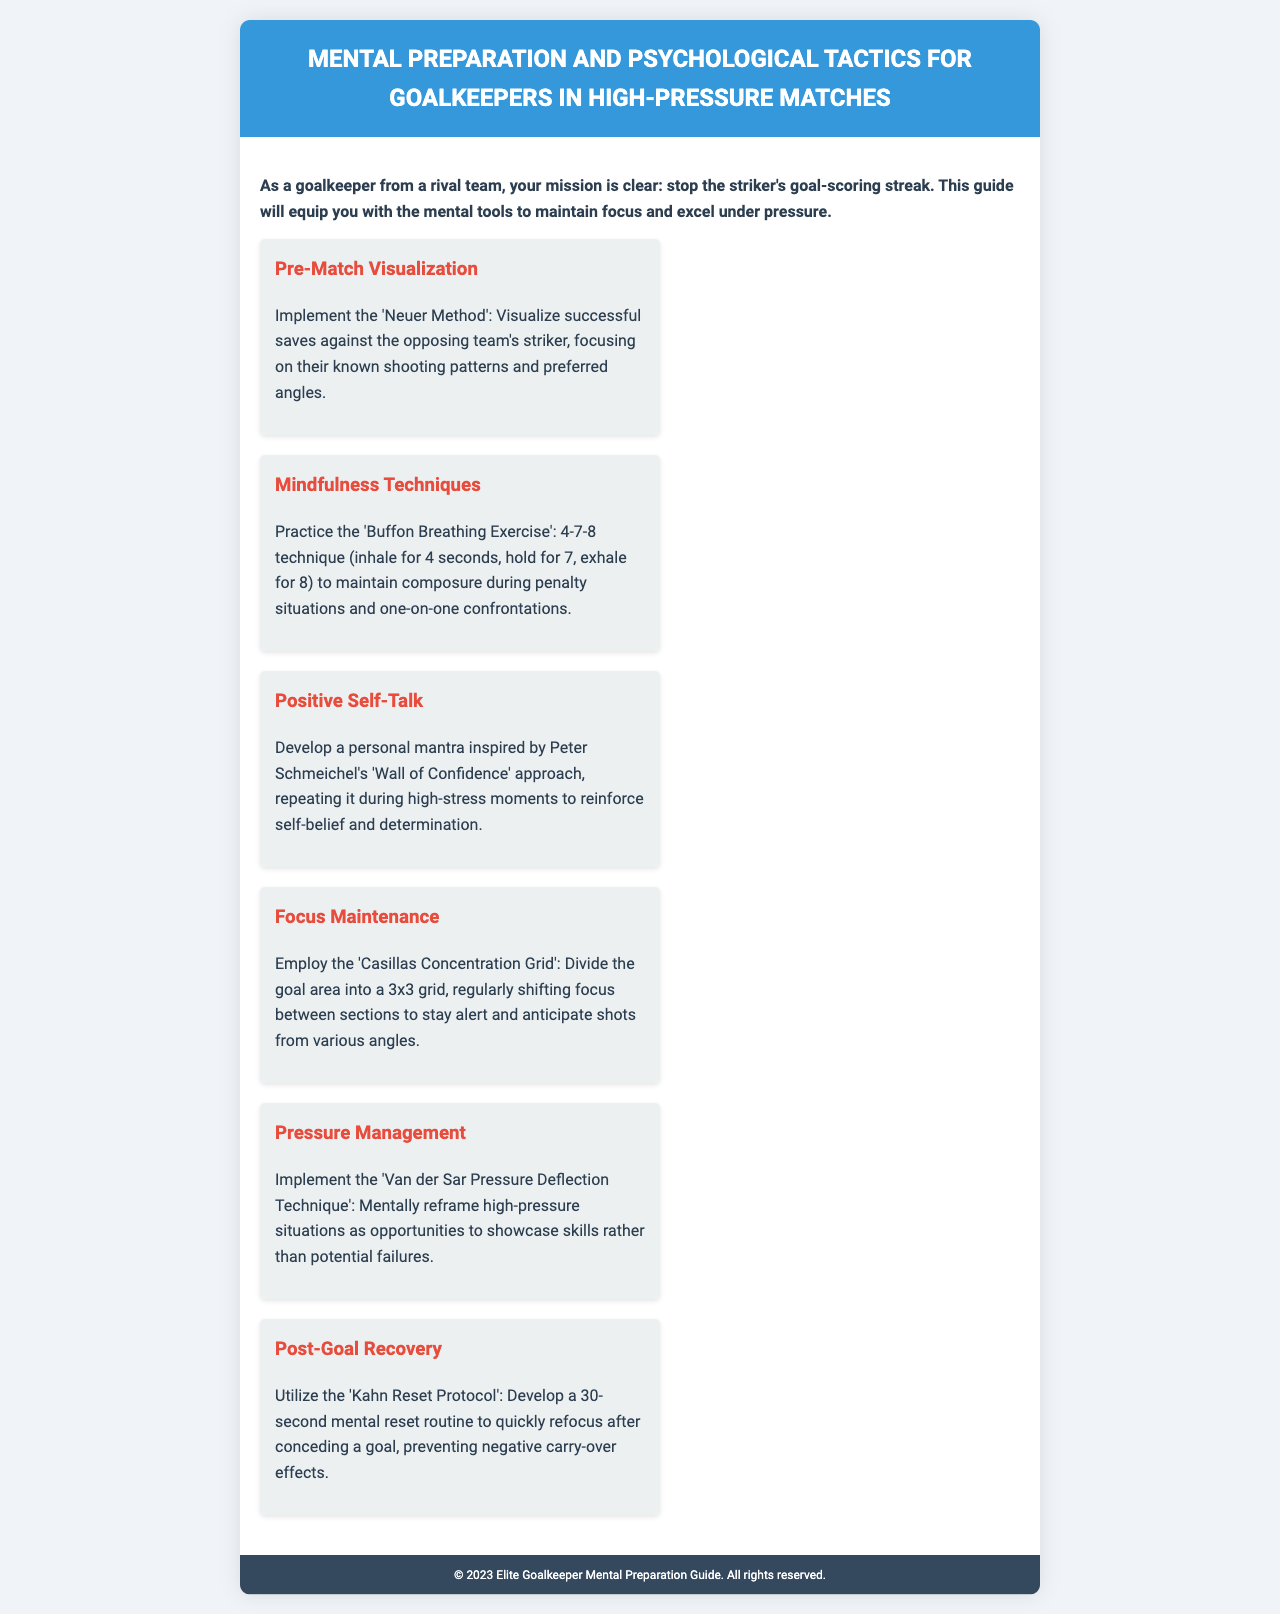What is the title of the document? The title of the document is presented prominently at the top of the rendered page, indicating the subject it covers.
Answer: Mental Preparation and Psychological Tactics for Goalkeepers in High-Pressure Matches What is the first psychological tactic mentioned? The first tactic outlined in the document aims to help goalkeepers visualize their successful performance before the match begins.
Answer: Pre-Match Visualization What breathing technique is suggested for mindfulness? The technique described involves breathing patterns to help maintain composure during critical moments, specifically related to anxiety and focus.
Answer: Buffon Breathing Exercise How many tactics are listed in the guide? The document provides a clear view of the total number of psychological strategies that it offers to goalkeepers.
Answer: Six Which goalkeeper's method emphasizes positive self-talk? The method encourages developing affirmations to boost confidence during high-pressure situations, inspired by a renowned goalkeeper.
Answer: Peter Schmeichel's 'Wall of Confidence' What technique helps with focus maintenance? The tactic promotes a strategic way to keep concentration during the game by dividing the goal area into sections.
Answer: Casillas Concentration Grid What is the purpose of the Kahn Reset Protocol? This protocol aims to establish a quick routine for goalkeepers to regain focus after experiencing a setback in the game.
Answer: 30-second mental reset routine What does the Van der Sar technique suggest about high-pressure situations? This method encourages goalkeepers to change their mindset regarding pressure, suggesting it can be a chance to demonstrate their abilities.
Answer: Opportunities to showcase skills 